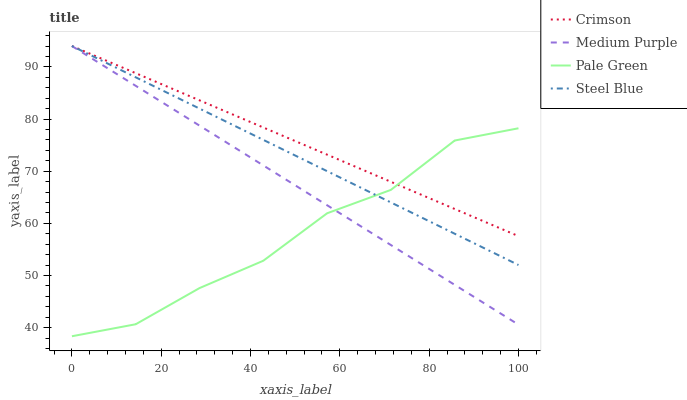Does Pale Green have the minimum area under the curve?
Answer yes or no. Yes. Does Crimson have the maximum area under the curve?
Answer yes or no. Yes. Does Medium Purple have the minimum area under the curve?
Answer yes or no. No. Does Medium Purple have the maximum area under the curve?
Answer yes or no. No. Is Steel Blue the smoothest?
Answer yes or no. Yes. Is Pale Green the roughest?
Answer yes or no. Yes. Is Medium Purple the smoothest?
Answer yes or no. No. Is Medium Purple the roughest?
Answer yes or no. No. Does Medium Purple have the lowest value?
Answer yes or no. No. Does Steel Blue have the highest value?
Answer yes or no. Yes. Does Pale Green have the highest value?
Answer yes or no. No. Does Medium Purple intersect Pale Green?
Answer yes or no. Yes. Is Medium Purple less than Pale Green?
Answer yes or no. No. Is Medium Purple greater than Pale Green?
Answer yes or no. No. 